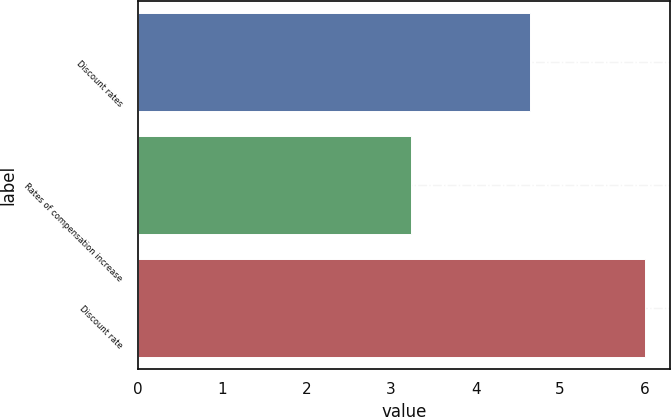Convert chart to OTSL. <chart><loc_0><loc_0><loc_500><loc_500><bar_chart><fcel>Discount rates<fcel>Rates of compensation increase<fcel>Discount rate<nl><fcel>4.64<fcel>3.24<fcel>6<nl></chart> 